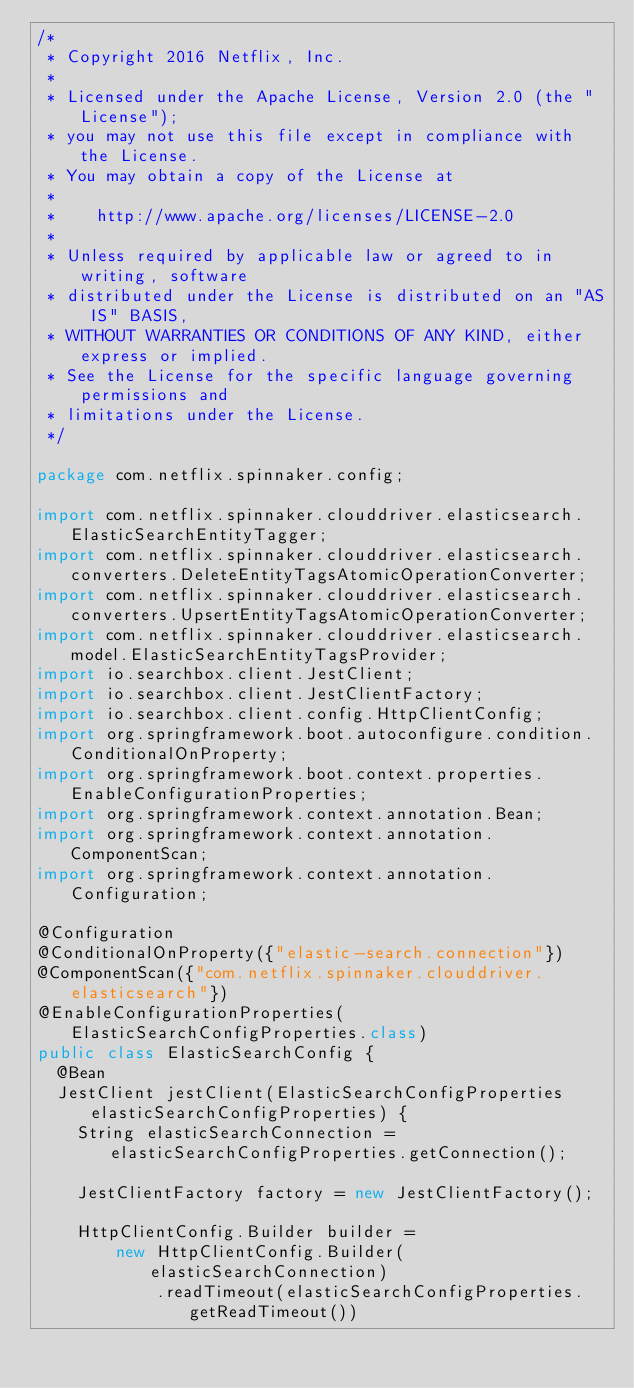<code> <loc_0><loc_0><loc_500><loc_500><_Java_>/*
 * Copyright 2016 Netflix, Inc.
 *
 * Licensed under the Apache License, Version 2.0 (the "License");
 * you may not use this file except in compliance with the License.
 * You may obtain a copy of the License at
 *
 *    http://www.apache.org/licenses/LICENSE-2.0
 *
 * Unless required by applicable law or agreed to in writing, software
 * distributed under the License is distributed on an "AS IS" BASIS,
 * WITHOUT WARRANTIES OR CONDITIONS OF ANY KIND, either express or implied.
 * See the License for the specific language governing permissions and
 * limitations under the License.
 */

package com.netflix.spinnaker.config;

import com.netflix.spinnaker.clouddriver.elasticsearch.ElasticSearchEntityTagger;
import com.netflix.spinnaker.clouddriver.elasticsearch.converters.DeleteEntityTagsAtomicOperationConverter;
import com.netflix.spinnaker.clouddriver.elasticsearch.converters.UpsertEntityTagsAtomicOperationConverter;
import com.netflix.spinnaker.clouddriver.elasticsearch.model.ElasticSearchEntityTagsProvider;
import io.searchbox.client.JestClient;
import io.searchbox.client.JestClientFactory;
import io.searchbox.client.config.HttpClientConfig;
import org.springframework.boot.autoconfigure.condition.ConditionalOnProperty;
import org.springframework.boot.context.properties.EnableConfigurationProperties;
import org.springframework.context.annotation.Bean;
import org.springframework.context.annotation.ComponentScan;
import org.springframework.context.annotation.Configuration;

@Configuration
@ConditionalOnProperty({"elastic-search.connection"})
@ComponentScan({"com.netflix.spinnaker.clouddriver.elasticsearch"})
@EnableConfigurationProperties(ElasticSearchConfigProperties.class)
public class ElasticSearchConfig {
  @Bean
  JestClient jestClient(ElasticSearchConfigProperties elasticSearchConfigProperties) {
    String elasticSearchConnection = elasticSearchConfigProperties.getConnection();

    JestClientFactory factory = new JestClientFactory();

    HttpClientConfig.Builder builder =
        new HttpClientConfig.Builder(elasticSearchConnection)
            .readTimeout(elasticSearchConfigProperties.getReadTimeout())</code> 